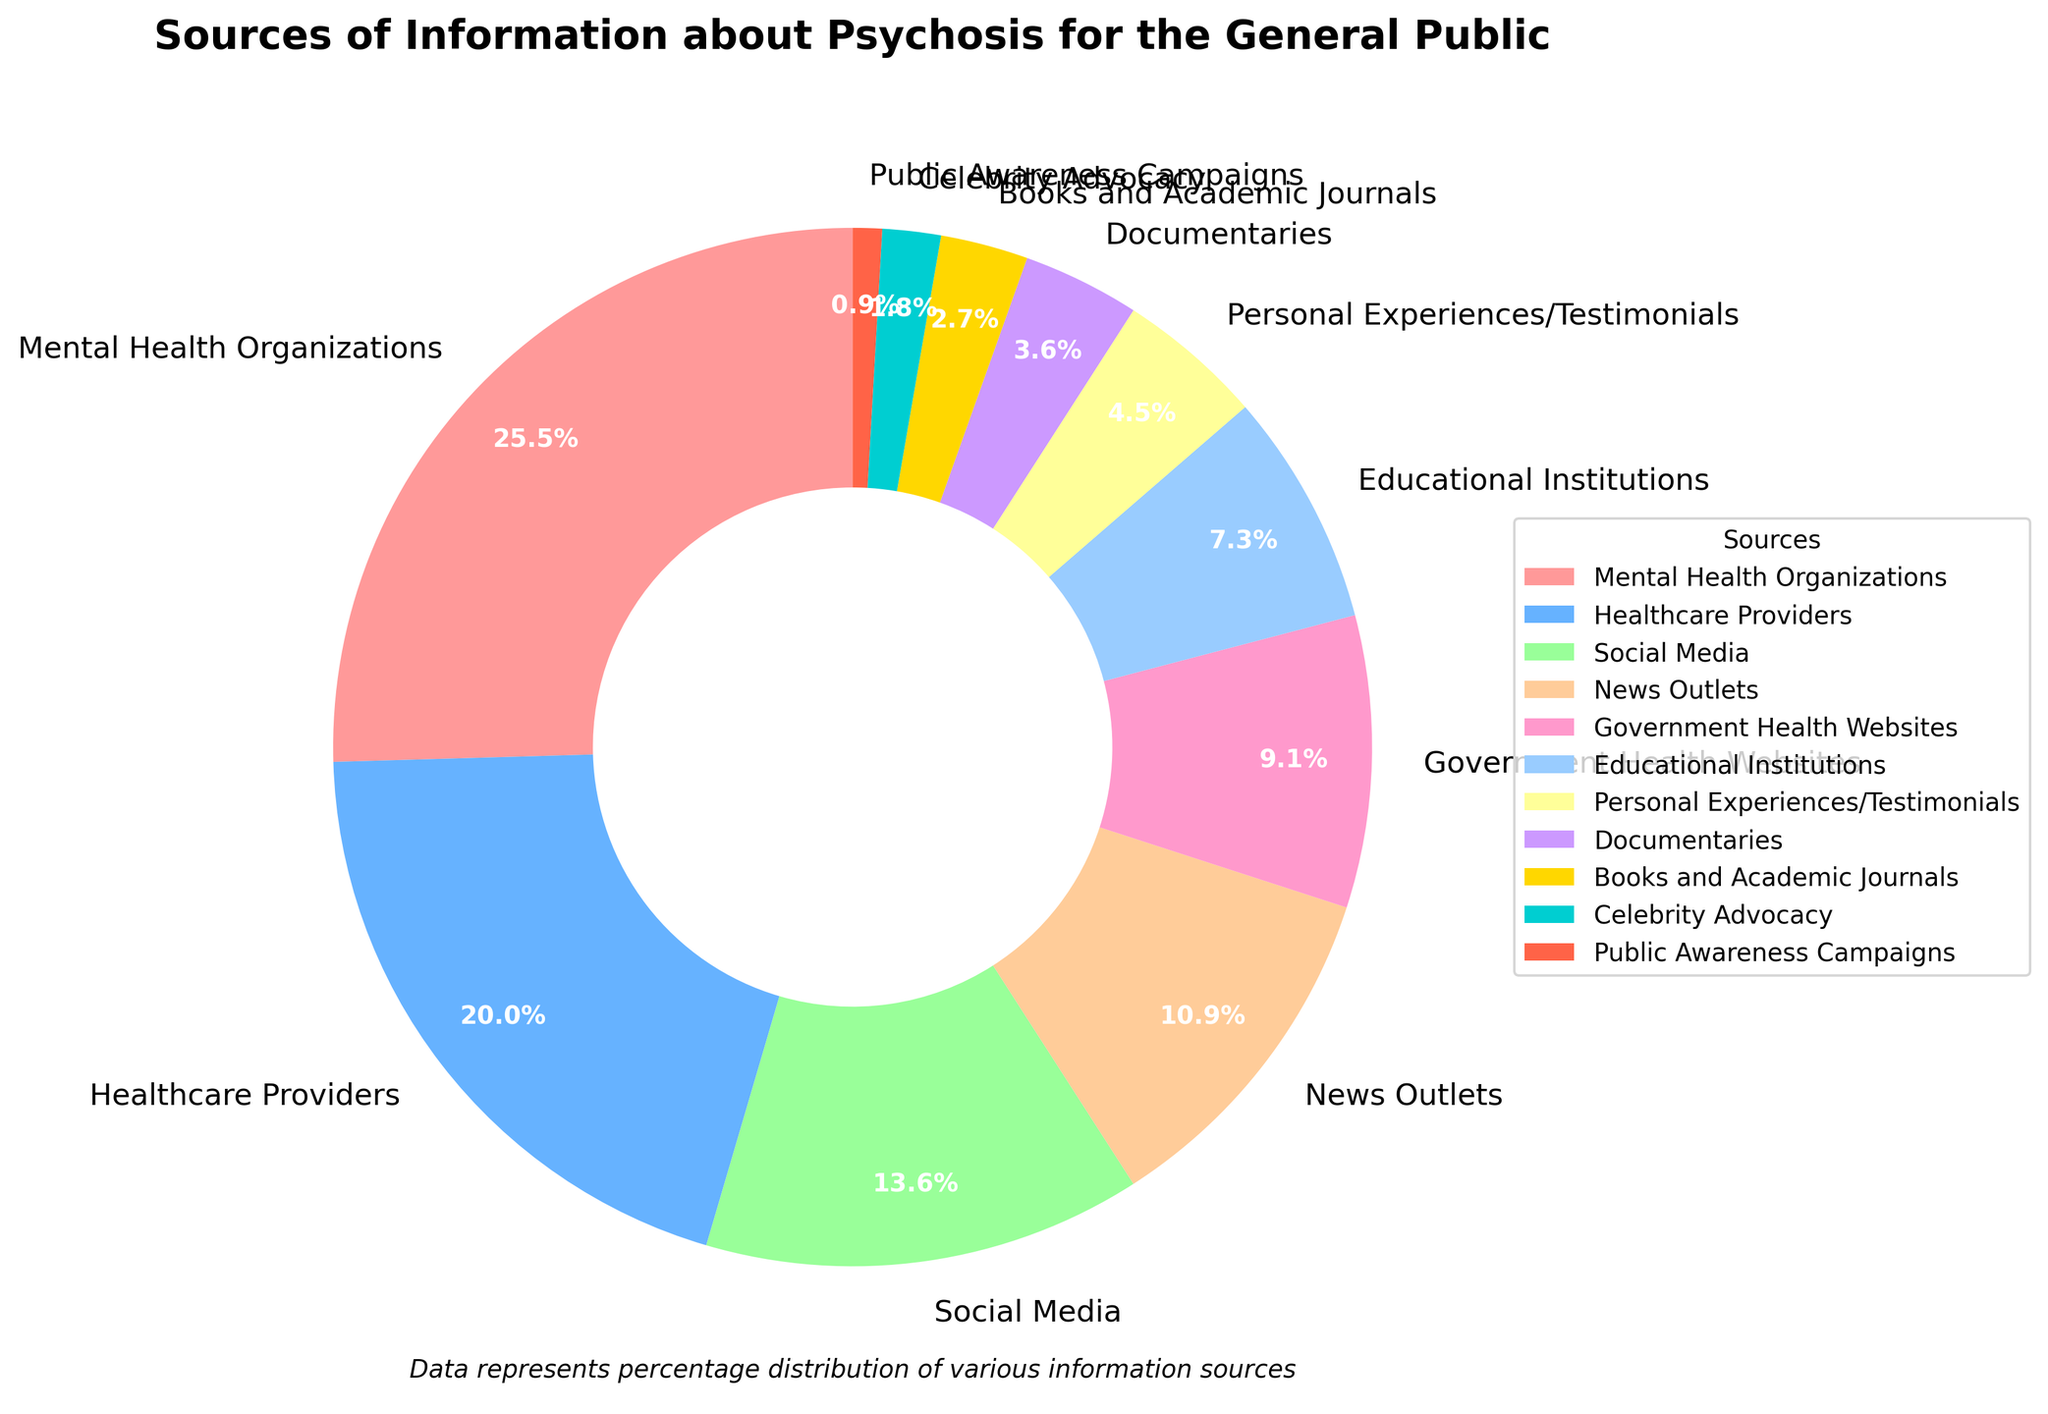Which source of information is the most common among the general public? The pie chart shows that "Mental Health Organizations" have the largest percentage share, indicating it's the most common source of information about psychosis.
Answer: Mental Health Organizations Which source of information is the least common according to the data? The slice for "Public Awareness Campaigns" shows the smallest percentage share, making it the least common source of information about psychosis.
Answer: Public Awareness Campaigns How does the percentage for Healthcare Providers compare to Social Media? The pie chart indicates that Healthcare Providers account for 22%, while Social Media accounts for 15%. Since 22% is larger than 15%, Healthcare Providers are a more common source compared to Social Media.
Answer: Healthcare Providers What is the combined percentage of Social Media and News Outlets? According to the pie chart, Social Media accounts for 15% and News Outlets account for 12%. The combined percentage is 15% + 12% = 27%.
Answer: 27% Are Mental Health Organizations and Government Health Websites together more than or less than the total percentage of Educational Institutions and Personal Experiences/Testimonials? Mental Health Organizations account for 28%, and Government Health Websites account for 10%. Adding these gives us 28% + 10% = 38%. Educational Institutions are 8% and Personal Experiences/Testimonials are 5%, for a total of 8% + 5% = 13%. Since 38% is greater than 13%, the combined percentage of Mental Health Organizations and Government Health Websites is more.
Answer: More Which two sources have the smallest percentages individually? According to the pie chart, Celebrity Advocacy (2%) and Public Awareness Campaigns (1%) have the smallest percentages.
Answer: Celebrity Advocacy and Public Awareness Campaigns Is the percentage share of Healthcare Providers more than double that of Documentaries? Documentaries account for 4%, and Healthcare Providers account for 22%. Double the percentage of Documentaries would be 4% * 2 = 8%. Since 22% is greater than 8%, the share of Healthcare Providers is more than double that of Documentaries.
Answer: Yes What's the total percentage share of sources that individually account for more than 10%? Sources with more than 10% are Mental Health Organizations (28%), Healthcare Providers (22%), Social Media (15%), and News Outlets (12%). Adding these together: 28 + 22 + 15 + 12 = 77%.
Answer: 77% Which color is used to represent the source with the second-highest percentage? The pie chart uses distinct colors for each source. The second-highest percentage, Healthcare Providers (22%), would be represented in a specific color. By identifying the color of the wedge for Healthcare Providers, we can determine the color used.
Answer: Blue (assuming Healthcare Providers is the second-largest slice from the provided code) Which sources have a percentage share between 10% and 20%? From the pie chart, the sources within this range are Social Media (15%) and News Outlets (12%).
Answer: Social Media and News Outlets 